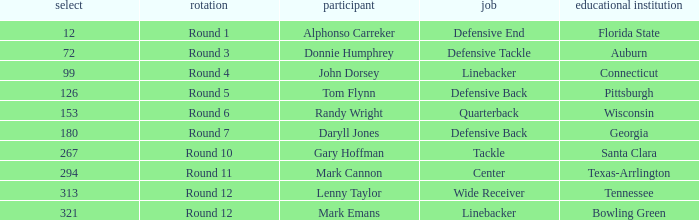In what Round was a player from College of Connecticut drafted? Round 4. 